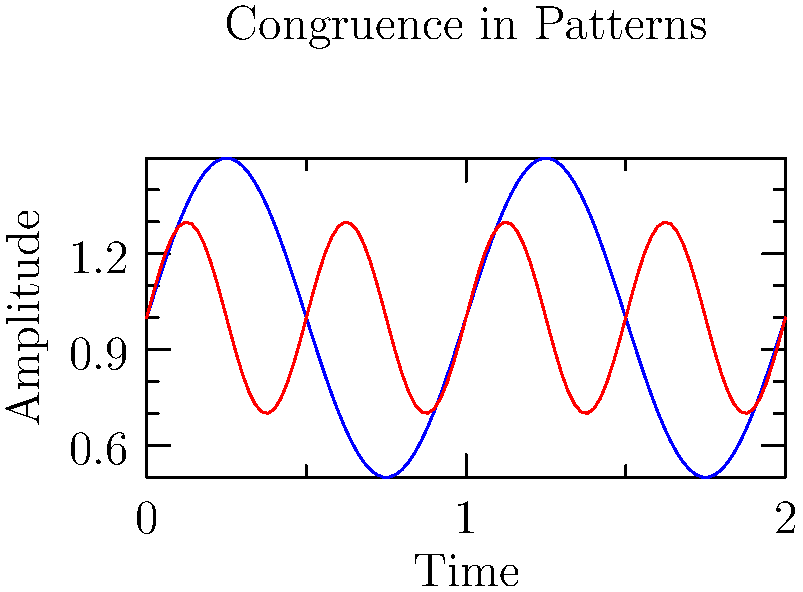Analyze the graph showing the patterns of musical rhythm (blue) and heart rate variability (red). Which mathematical concept best describes the relationship between these two waveforms, and how might this influence the neurological response to music? To answer this question, let's analyze the graph step-by-step:

1. Observe the waveforms: Both the blue (musical rhythm) and red (heart rate variability) lines show sinusoidal patterns.

2. Compare frequencies: The blue line completes one full cycle in the given time frame, while the red line completes two cycles.

3. Identify the mathematical relationship: The red line's frequency is exactly twice that of the blue line. This relationship is known as harmonic synchronization or frequency entrainment.

4. Consider the amplitudes: The blue line has a larger amplitude (0.5) compared to the red line (0.3), but both oscillate around a mean of 1.

5. Analyze phase alignment: The peaks and troughs of both waveforms align at regular intervals, indicating phase coherence.

6. Mathematical concept: The relationship between these waveforms can be described as congruence, specifically harmonic congruence. This is because:
   a) Their frequencies are related by a simple integer ratio (2:1)
   b) They show phase alignment at regular intervals
   c) Both waveforms can be described by similar sinusoidal functions

7. Neurological influence: This congruence suggests that the brain might process musical rhythms and heart rate variability patterns similarly. The harmonic relationship could lead to:
   a) Enhanced emotional responses to music
   b) Improved cognitive processing of musical structures
   c) Potential therapeutic applications in music therapy for cardiovascular health

In conclusion, the congruence between these patterns implies a deep connection between musical perception and physiological processes, which could have significant implications for understanding the neurological effects of music.
Answer: Harmonic congruence 